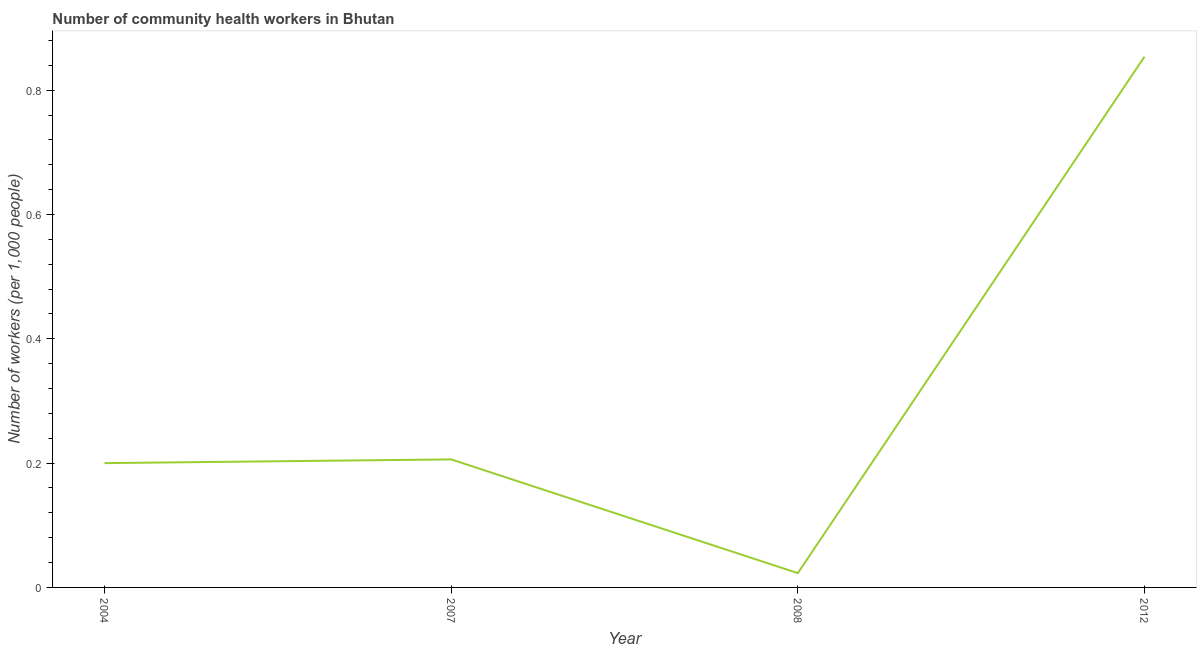Across all years, what is the maximum number of community health workers?
Make the answer very short. 0.85. Across all years, what is the minimum number of community health workers?
Your answer should be compact. 0.02. What is the sum of the number of community health workers?
Ensure brevity in your answer.  1.28. What is the difference between the number of community health workers in 2004 and 2008?
Make the answer very short. 0.18. What is the average number of community health workers per year?
Give a very brief answer. 0.32. What is the median number of community health workers?
Ensure brevity in your answer.  0.2. What is the ratio of the number of community health workers in 2007 to that in 2012?
Ensure brevity in your answer.  0.24. Is the difference between the number of community health workers in 2007 and 2008 greater than the difference between any two years?
Provide a short and direct response. No. What is the difference between the highest and the second highest number of community health workers?
Your response must be concise. 0.65. What is the difference between the highest and the lowest number of community health workers?
Provide a succinct answer. 0.83. In how many years, is the number of community health workers greater than the average number of community health workers taken over all years?
Provide a succinct answer. 1. Does the number of community health workers monotonically increase over the years?
Offer a terse response. No. How many lines are there?
Offer a very short reply. 1. Does the graph contain grids?
Make the answer very short. No. What is the title of the graph?
Your answer should be compact. Number of community health workers in Bhutan. What is the label or title of the Y-axis?
Your response must be concise. Number of workers (per 1,0 people). What is the Number of workers (per 1,000 people) in 2007?
Ensure brevity in your answer.  0.21. What is the Number of workers (per 1,000 people) of 2008?
Your answer should be very brief. 0.02. What is the Number of workers (per 1,000 people) of 2012?
Your answer should be very brief. 0.85. What is the difference between the Number of workers (per 1,000 people) in 2004 and 2007?
Your answer should be compact. -0.01. What is the difference between the Number of workers (per 1,000 people) in 2004 and 2008?
Your answer should be very brief. 0.18. What is the difference between the Number of workers (per 1,000 people) in 2004 and 2012?
Offer a very short reply. -0.65. What is the difference between the Number of workers (per 1,000 people) in 2007 and 2008?
Your answer should be compact. 0.18. What is the difference between the Number of workers (per 1,000 people) in 2007 and 2012?
Keep it short and to the point. -0.65. What is the difference between the Number of workers (per 1,000 people) in 2008 and 2012?
Provide a short and direct response. -0.83. What is the ratio of the Number of workers (per 1,000 people) in 2004 to that in 2007?
Keep it short and to the point. 0.97. What is the ratio of the Number of workers (per 1,000 people) in 2004 to that in 2008?
Your response must be concise. 8.7. What is the ratio of the Number of workers (per 1,000 people) in 2004 to that in 2012?
Keep it short and to the point. 0.23. What is the ratio of the Number of workers (per 1,000 people) in 2007 to that in 2008?
Ensure brevity in your answer.  8.96. What is the ratio of the Number of workers (per 1,000 people) in 2007 to that in 2012?
Give a very brief answer. 0.24. What is the ratio of the Number of workers (per 1,000 people) in 2008 to that in 2012?
Your answer should be very brief. 0.03. 